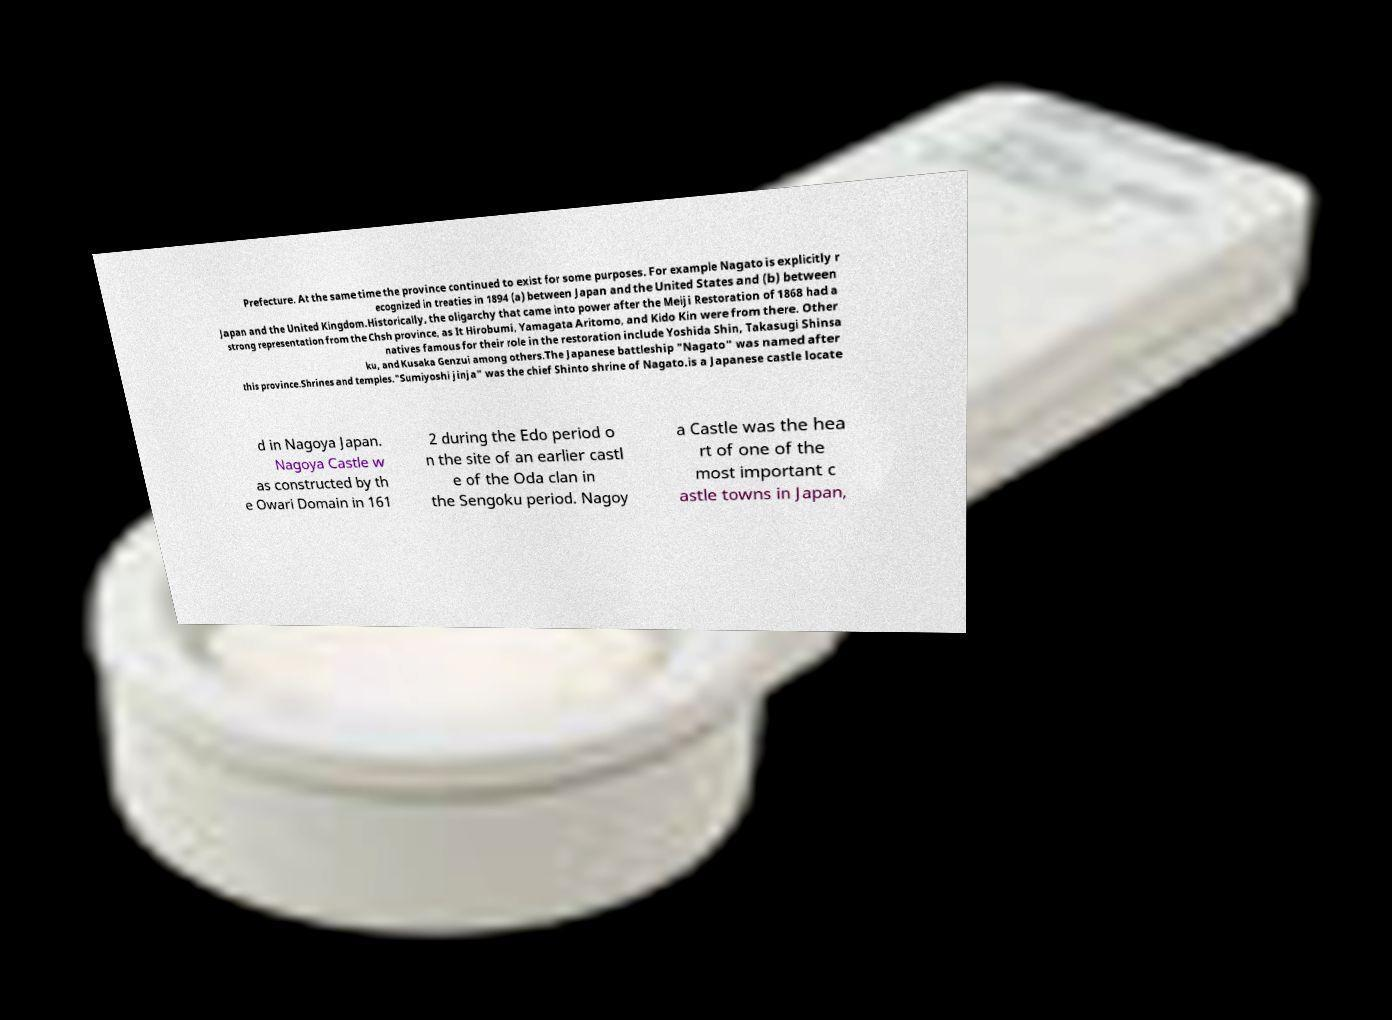Can you read and provide the text displayed in the image?This photo seems to have some interesting text. Can you extract and type it out for me? Prefecture. At the same time the province continued to exist for some purposes. For example Nagato is explicitly r ecognized in treaties in 1894 (a) between Japan and the United States and (b) between Japan and the United Kingdom.Historically, the oligarchy that came into power after the Meiji Restoration of 1868 had a strong representation from the Chsh province, as It Hirobumi, Yamagata Aritomo, and Kido Kin were from there. Other natives famous for their role in the restoration include Yoshida Shin, Takasugi Shinsa ku, and Kusaka Genzui among others.The Japanese battleship "Nagato" was named after this province.Shrines and temples."Sumiyoshi jinja" was the chief Shinto shrine of Nagato.is a Japanese castle locate d in Nagoya Japan. Nagoya Castle w as constructed by th e Owari Domain in 161 2 during the Edo period o n the site of an earlier castl e of the Oda clan in the Sengoku period. Nagoy a Castle was the hea rt of one of the most important c astle towns in Japan, 